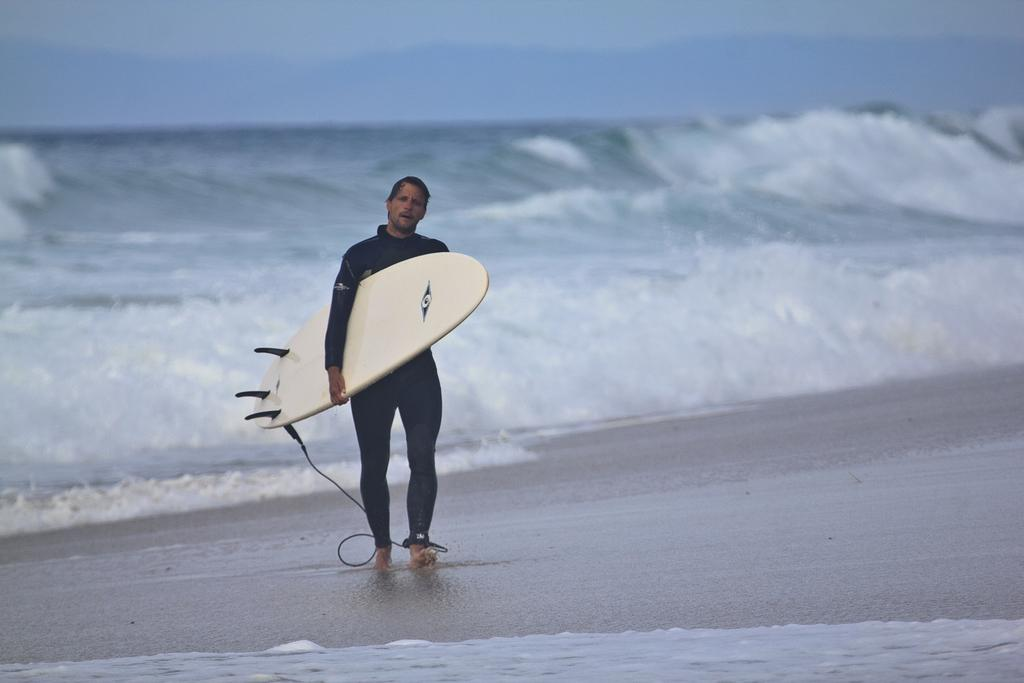What is the person in the image doing? The person is walking. What is the person holding while walking? The person is holding a surfboard. What type of water body is visible in the image? There is a fresh water river visible in the image. What is the condition of the water in the river? Waves are present in the river. What type of temper does the pot have in the image? There is no pot present in the image, so it is not possible to determine the temper of any pot. 